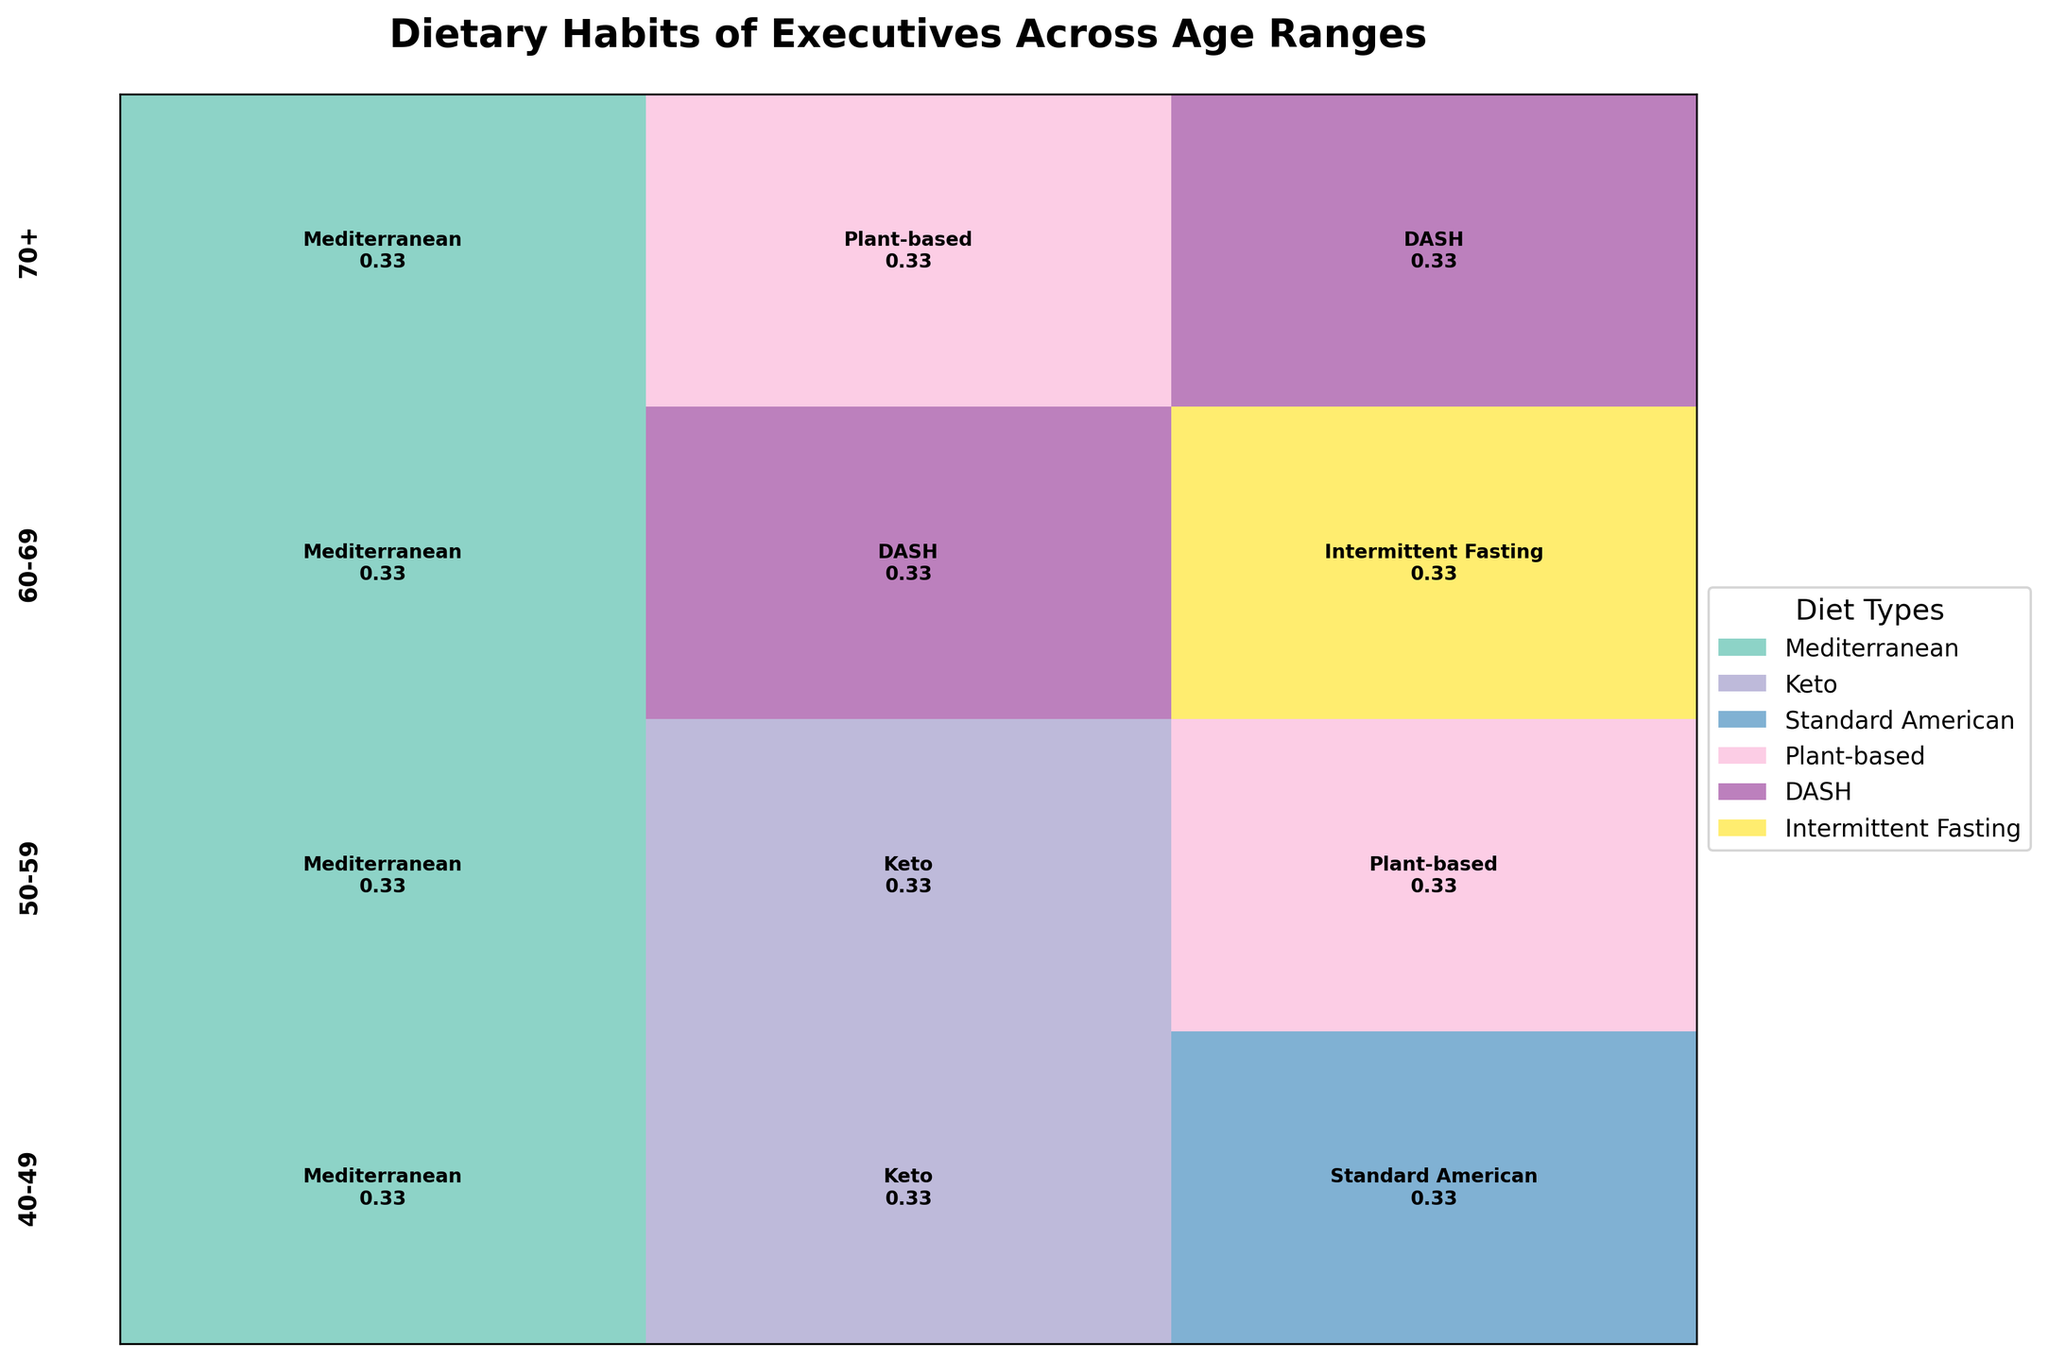How many diet types are represented in the 50-59 age range? In the 50-59 age range, we see Mediterranean, Keto, and Plant-based diet types. By looking at the plot, these are the distinct patches in this age section.
Answer: 3 Which age range has the highest proportion of executives following a Plant-based diet? By observing the plot, the 70+ age range shows the largest segment for the Plant-based diet compared to other age ranges.
Answer: 70+ Which dietary habit is most prevalent among 40-49-year-old executives? In the 40-49 age range, the Standard American diet takes up the largest proportion of the plot, indicating it's the most prevalent.
Answer: Standard American Compare the proportion of executives following the Keto diet between the 40-49 and 50-59 age ranges. The proportion of executives following the Keto diet is approximately the same in both the 40-49 and 50-59 age ranges, as the rectangles representing Keto are similar in size.
Answer: Similar in both ranges Which diet type in the 60-69 age range has the lowest fat intake, and what is its proportion? The DASH diet in the 60-69 age range represents the lowest-fat intake. The proportion is visible as a section of the plot, denoted by the corresponding color and labeling.
Answer: DASH, low Across all age ranges, which dietary habit tends to maintain a high intake of protein? Keto and Intermittent Fasting diets tend to maintain a high protein intake across different age ranges, as indicated by the text within the corresponding plot sections.
Answer: Keto and Intermittent Fasting Is there any age range where all represented diet types have moderate carbohydrate intake? In the 60-69 age range, all diet types (Mediterranean, DASH, Intermittent Fasting) have a moderate carbohydrate intake, as indicated by the plot labels.
Answer: 60-69 How does the proportion of executives following the Mediterranean diet change with age? The Mediterranean diet consistently appears across age ranges but is notably more prevalent in the 60-69 age range with the highest proportion compared to other ages.
Answer: Increases notably at 60-69 Between the 50-59 and 70+ age ranges, which has a larger proportion following the DASH diet? By looking at the plot sections, the 70+ age range has a notably larger proportion of the DASH diet compared to the 50-59 age range.
Answer: 70+ In the 60-69 age range, what are the carbohydrate intake levels for the diet types represented? All diet types in the 60-69 age range (Mediterranean, DASH, Intermittent Fasting) show a moderate carbohydrate intake as indicated in the plot.
Answer: Moderate for all 